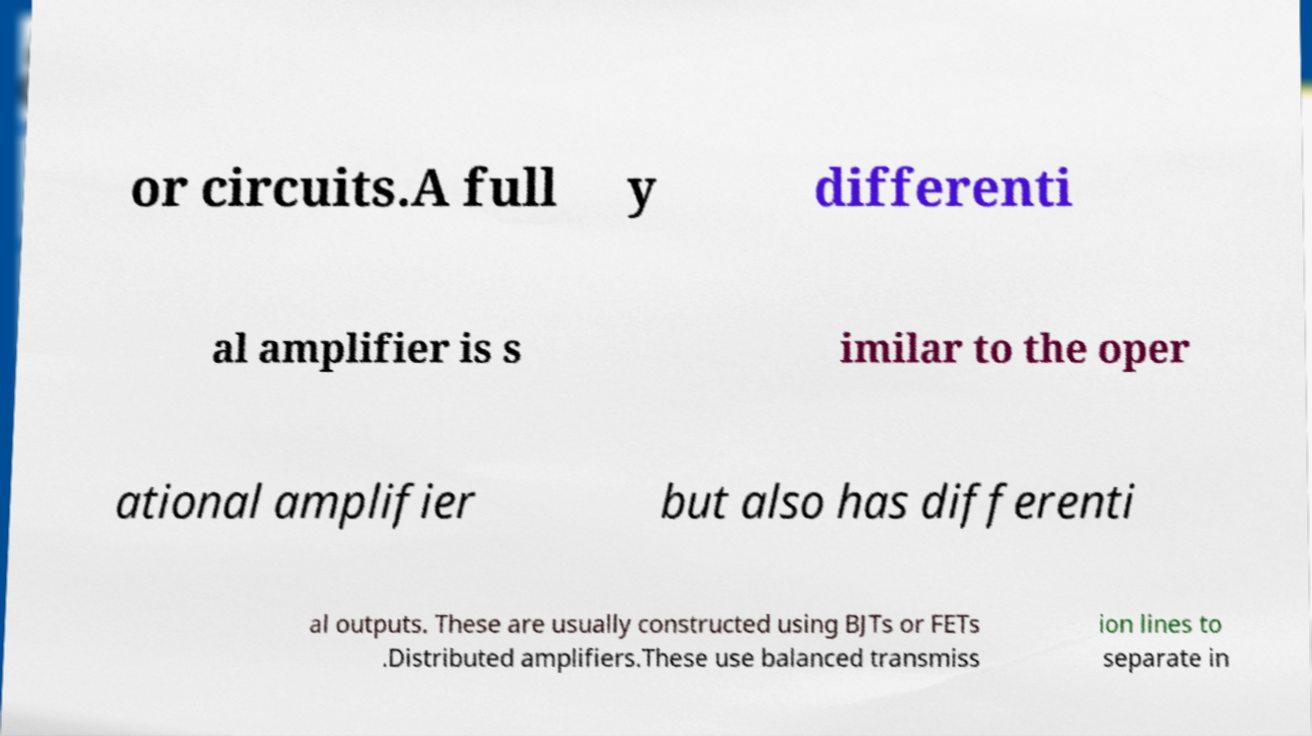What messages or text are displayed in this image? I need them in a readable, typed format. or circuits.A full y differenti al amplifier is s imilar to the oper ational amplifier but also has differenti al outputs. These are usually constructed using BJTs or FETs .Distributed amplifiers.These use balanced transmiss ion lines to separate in 